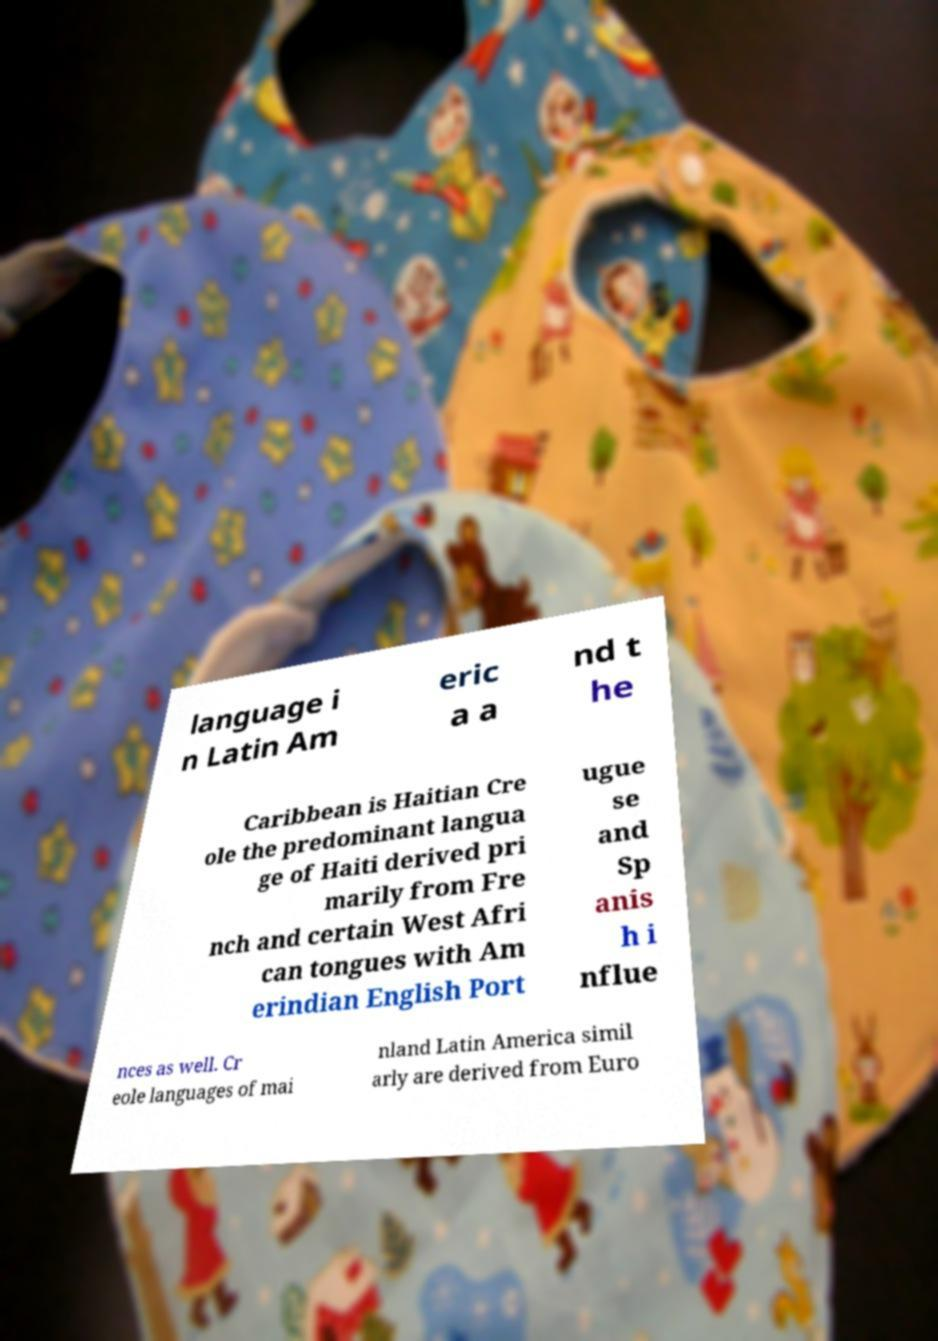I need the written content from this picture converted into text. Can you do that? language i n Latin Am eric a a nd t he Caribbean is Haitian Cre ole the predominant langua ge of Haiti derived pri marily from Fre nch and certain West Afri can tongues with Am erindian English Port ugue se and Sp anis h i nflue nces as well. Cr eole languages of mai nland Latin America simil arly are derived from Euro 